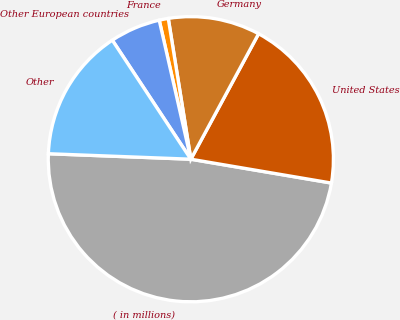<chart> <loc_0><loc_0><loc_500><loc_500><pie_chart><fcel>( in millions)<fcel>United States<fcel>Germany<fcel>France<fcel>Other European countries<fcel>Other<nl><fcel>47.93%<fcel>19.79%<fcel>10.41%<fcel>1.03%<fcel>5.72%<fcel>15.1%<nl></chart> 